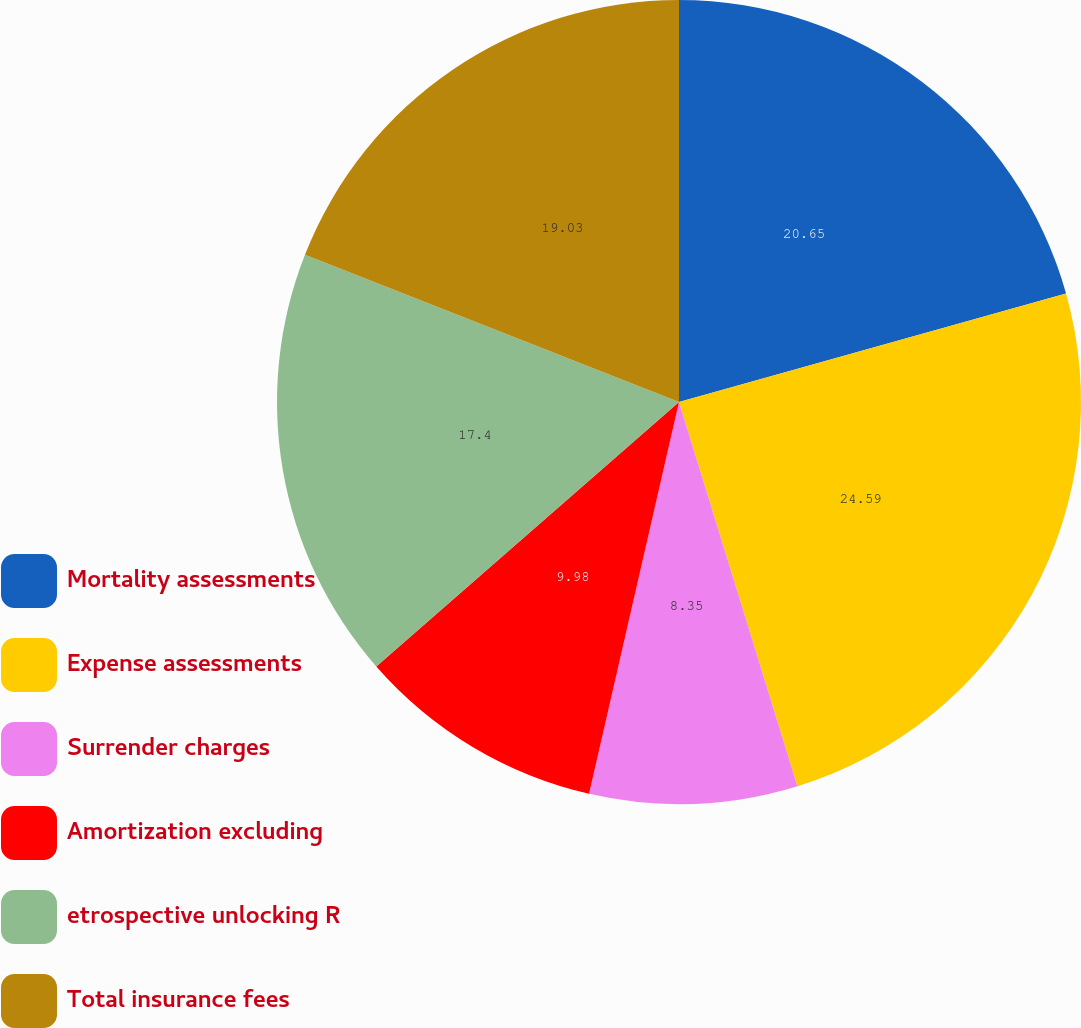<chart> <loc_0><loc_0><loc_500><loc_500><pie_chart><fcel>Mortality assessments<fcel>Expense assessments<fcel>Surrender charges<fcel>Amortization excluding<fcel>etrospective unlocking R<fcel>Total insurance fees<nl><fcel>20.65%<fcel>24.59%<fcel>8.35%<fcel>9.98%<fcel>17.4%<fcel>19.03%<nl></chart> 